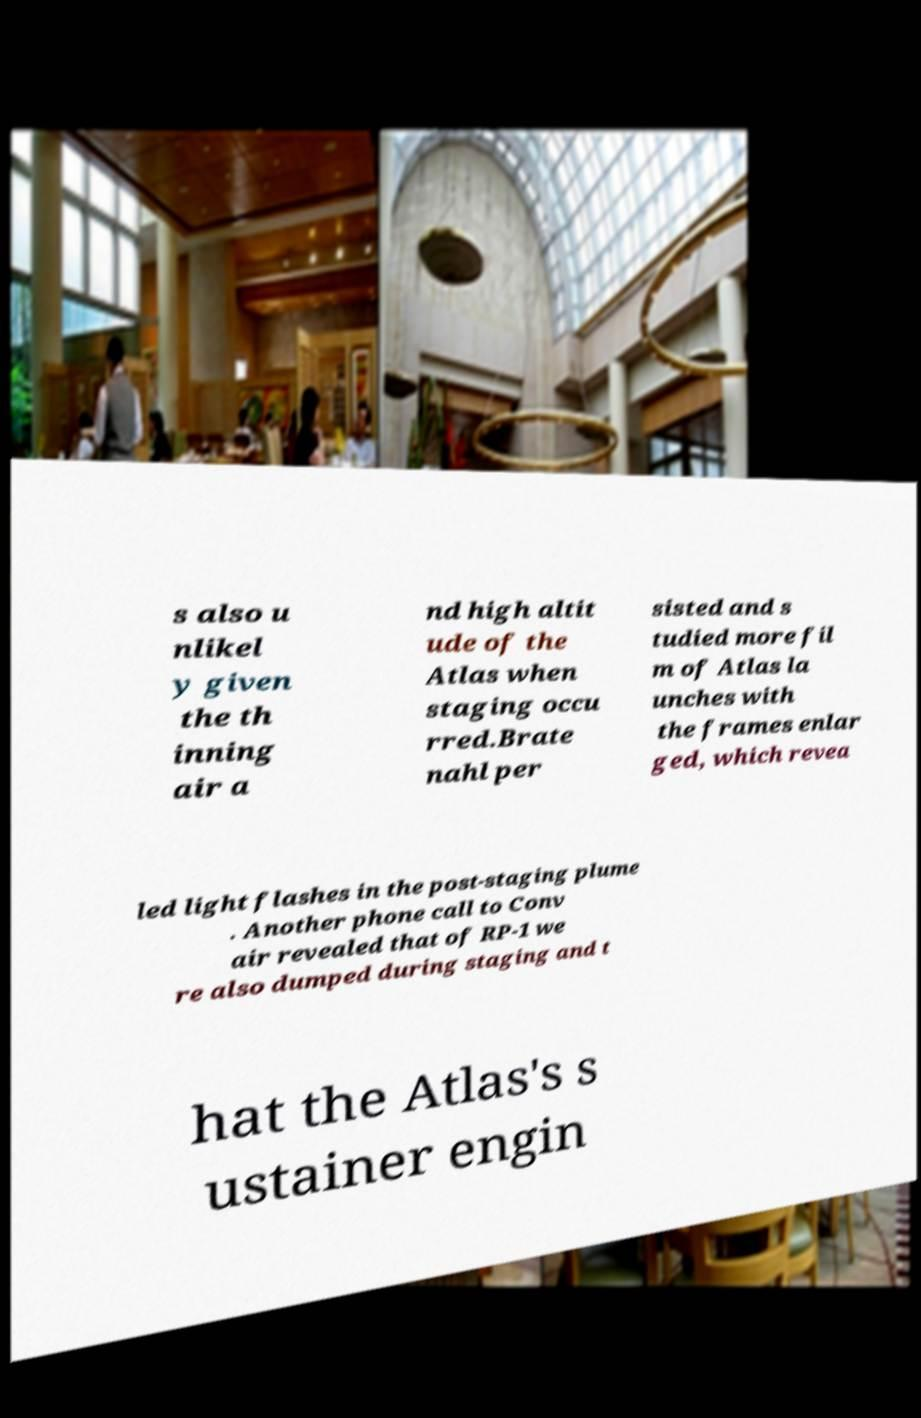There's text embedded in this image that I need extracted. Can you transcribe it verbatim? s also u nlikel y given the th inning air a nd high altit ude of the Atlas when staging occu rred.Brate nahl per sisted and s tudied more fil m of Atlas la unches with the frames enlar ged, which revea led light flashes in the post-staging plume . Another phone call to Conv air revealed that of RP-1 we re also dumped during staging and t hat the Atlas's s ustainer engin 